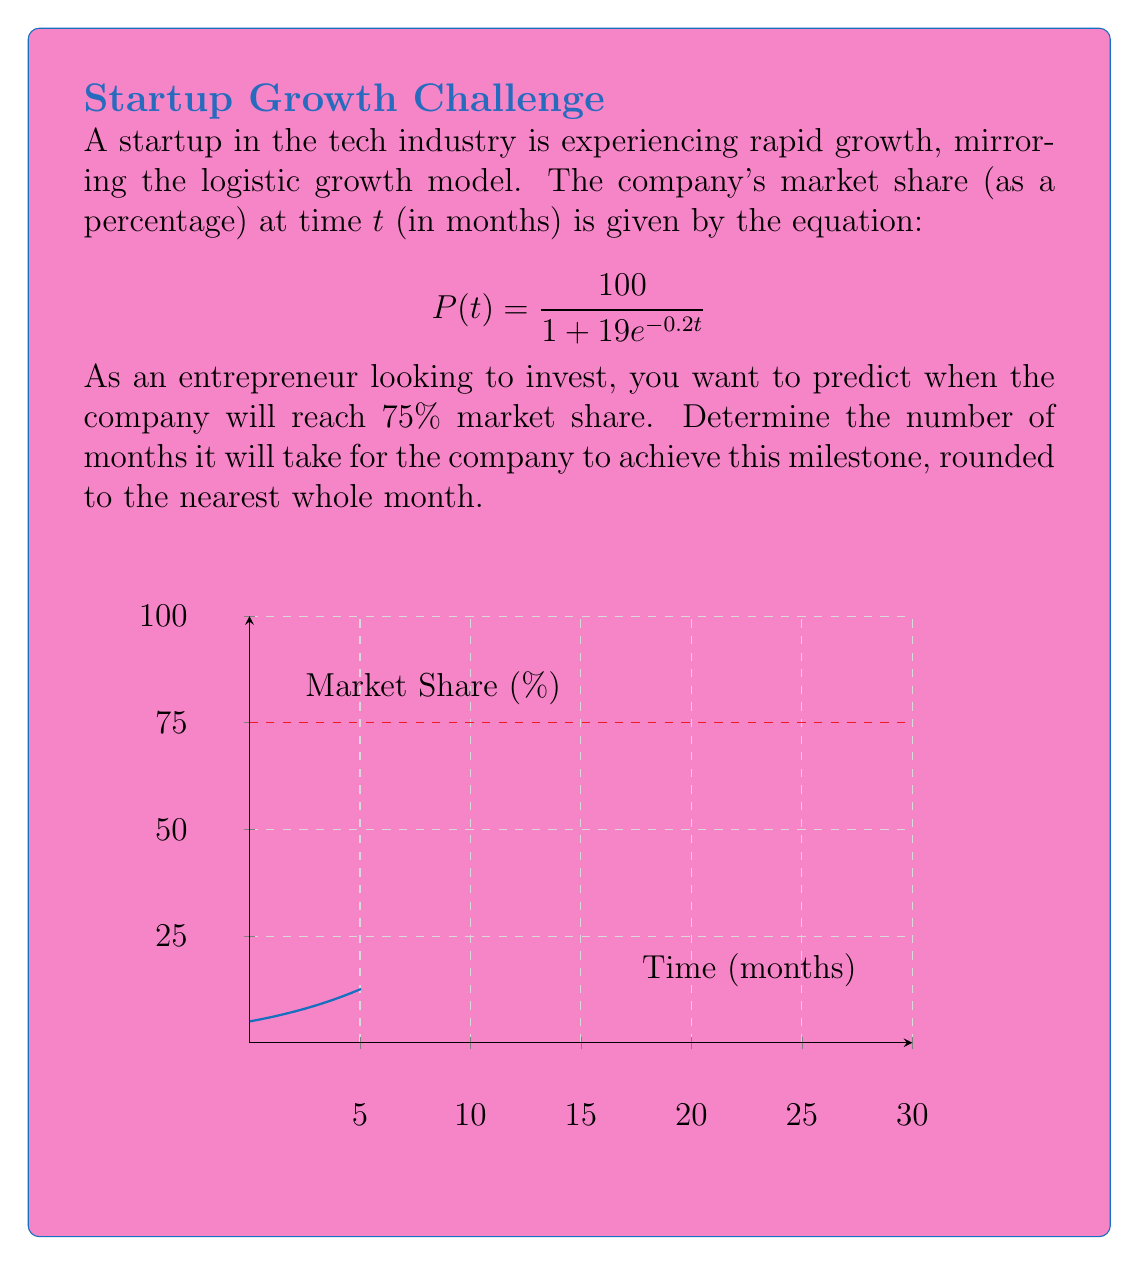Can you answer this question? To solve this problem, we'll follow these steps:

1) We need to find t when P(t) = 75. So, we set up the equation:

   $$75 = \frac{100}{1 + 19e^{-0.2t}}$$

2) Multiply both sides by $(1 + 19e^{-0.2t})$:

   $$75(1 + 19e^{-0.2t}) = 100$$

3) Distribute on the left side:

   $$75 + 1425e^{-0.2t} = 100$$

4) Subtract 75 from both sides:

   $$1425e^{-0.2t} = 25$$

5) Divide both sides by 1425:

   $$e^{-0.2t} = \frac{25}{1425} = \frac{1}{57}$$

6) Take the natural log of both sides:

   $$-0.2t = \ln(\frac{1}{57})$$

7) Divide both sides by -0.2:

   $$t = -\frac{\ln(\frac{1}{57})}{0.2}$$

8) Simplify:

   $$t = \frac{\ln(57)}{0.2} \approx 20.31$$

9) Round to the nearest whole month:

   $$t \approx 20$$ months
Answer: 20 months 